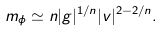Convert formula to latex. <formula><loc_0><loc_0><loc_500><loc_500>m _ { \phi } \simeq n | g | ^ { 1 / n } | v | ^ { 2 - 2 / n } .</formula> 